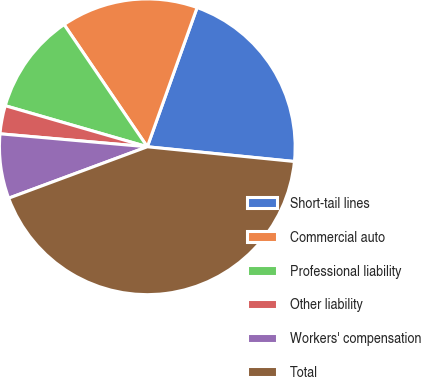Convert chart. <chart><loc_0><loc_0><loc_500><loc_500><pie_chart><fcel>Short-tail lines<fcel>Commercial auto<fcel>Professional liability<fcel>Other liability<fcel>Workers' compensation<fcel>Total<nl><fcel>21.12%<fcel>14.98%<fcel>11.01%<fcel>3.08%<fcel>7.05%<fcel>42.76%<nl></chart> 